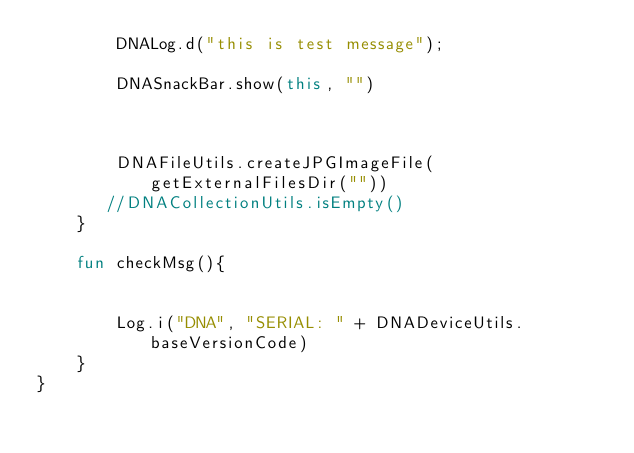<code> <loc_0><loc_0><loc_500><loc_500><_Kotlin_>        DNALog.d("this is test message");

        DNASnackBar.show(this, "")



        DNAFileUtils.createJPGImageFile(getExternalFilesDir(""))
       //DNACollectionUtils.isEmpty()
    }

    fun checkMsg(){


        Log.i("DNA", "SERIAL: " + DNADeviceUtils.baseVersionCode)
    }
}
</code> 